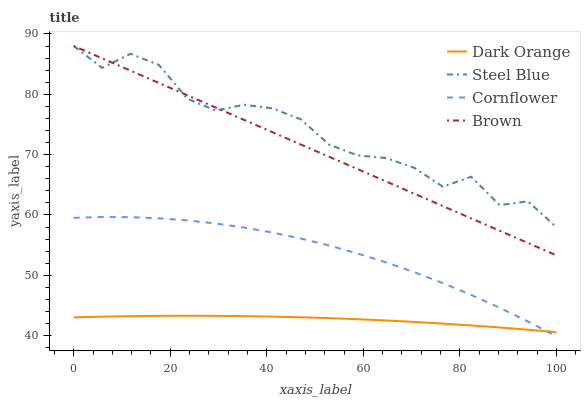Does Dark Orange have the minimum area under the curve?
Answer yes or no. Yes. Does Steel Blue have the maximum area under the curve?
Answer yes or no. Yes. Does Brown have the minimum area under the curve?
Answer yes or no. No. Does Brown have the maximum area under the curve?
Answer yes or no. No. Is Brown the smoothest?
Answer yes or no. Yes. Is Steel Blue the roughest?
Answer yes or no. Yes. Is Steel Blue the smoothest?
Answer yes or no. No. Is Brown the roughest?
Answer yes or no. No. Does Brown have the lowest value?
Answer yes or no. No. Does Brown have the highest value?
Answer yes or no. Yes. Does Cornflower have the highest value?
Answer yes or no. No. Is Cornflower less than Steel Blue?
Answer yes or no. Yes. Is Steel Blue greater than Cornflower?
Answer yes or no. Yes. Does Dark Orange intersect Cornflower?
Answer yes or no. Yes. Is Dark Orange less than Cornflower?
Answer yes or no. No. Is Dark Orange greater than Cornflower?
Answer yes or no. No. Does Cornflower intersect Steel Blue?
Answer yes or no. No. 